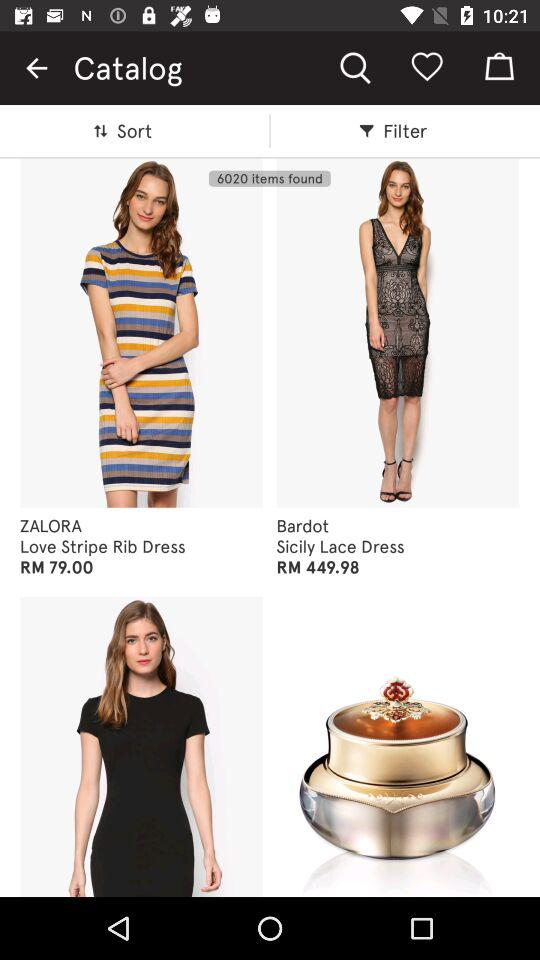What is the cost of the "Love Stripe Rib Dress"? The cost of the "Love Stripe Rib Dress" is RM79.00. 